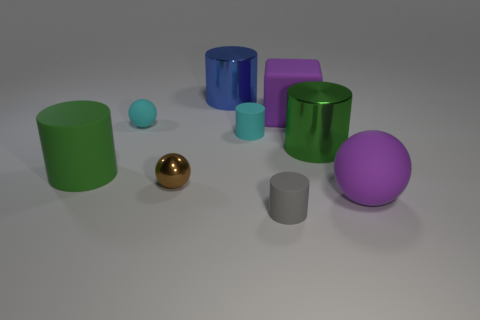What shape is the large thing that is the same color as the large matte sphere?
Keep it short and to the point. Cube. What size is the sphere that is the same color as the big cube?
Your response must be concise. Large. What material is the brown sphere that is on the left side of the purple object in front of the matte object left of the cyan ball made of?
Give a very brief answer. Metal. How many big yellow metallic balls are there?
Offer a terse response. 0. How many purple objects are shiny cylinders or cubes?
Provide a short and direct response. 1. How many other objects are there of the same shape as the brown object?
Provide a short and direct response. 2. Do the small rubber cylinder that is behind the large green shiny cylinder and the matte sphere on the left side of the purple rubber sphere have the same color?
Offer a very short reply. Yes. How many large objects are green things or purple cubes?
Keep it short and to the point. 3. What is the size of the cyan object that is the same shape as the small brown object?
Provide a succinct answer. Small. What is the material of the green cylinder left of the large cylinder behind the green metallic cylinder?
Give a very brief answer. Rubber. 